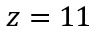<formula> <loc_0><loc_0><loc_500><loc_500>z = 1 1</formula> 